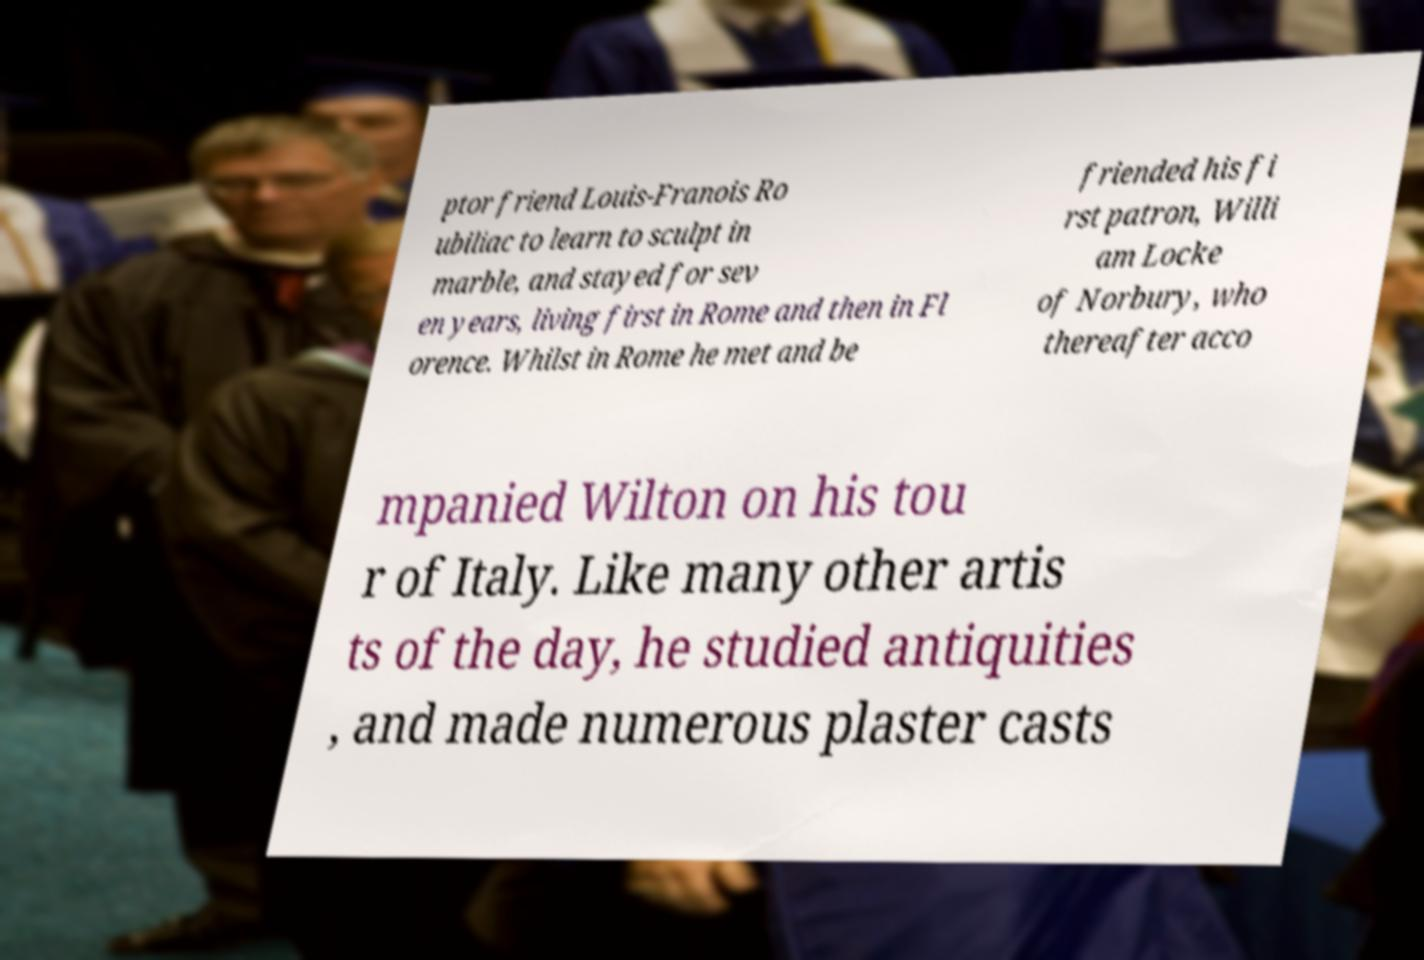Can you read and provide the text displayed in the image?This photo seems to have some interesting text. Can you extract and type it out for me? ptor friend Louis-Franois Ro ubiliac to learn to sculpt in marble, and stayed for sev en years, living first in Rome and then in Fl orence. Whilst in Rome he met and be friended his fi rst patron, Willi am Locke of Norbury, who thereafter acco mpanied Wilton on his tou r of Italy. Like many other artis ts of the day, he studied antiquities , and made numerous plaster casts 